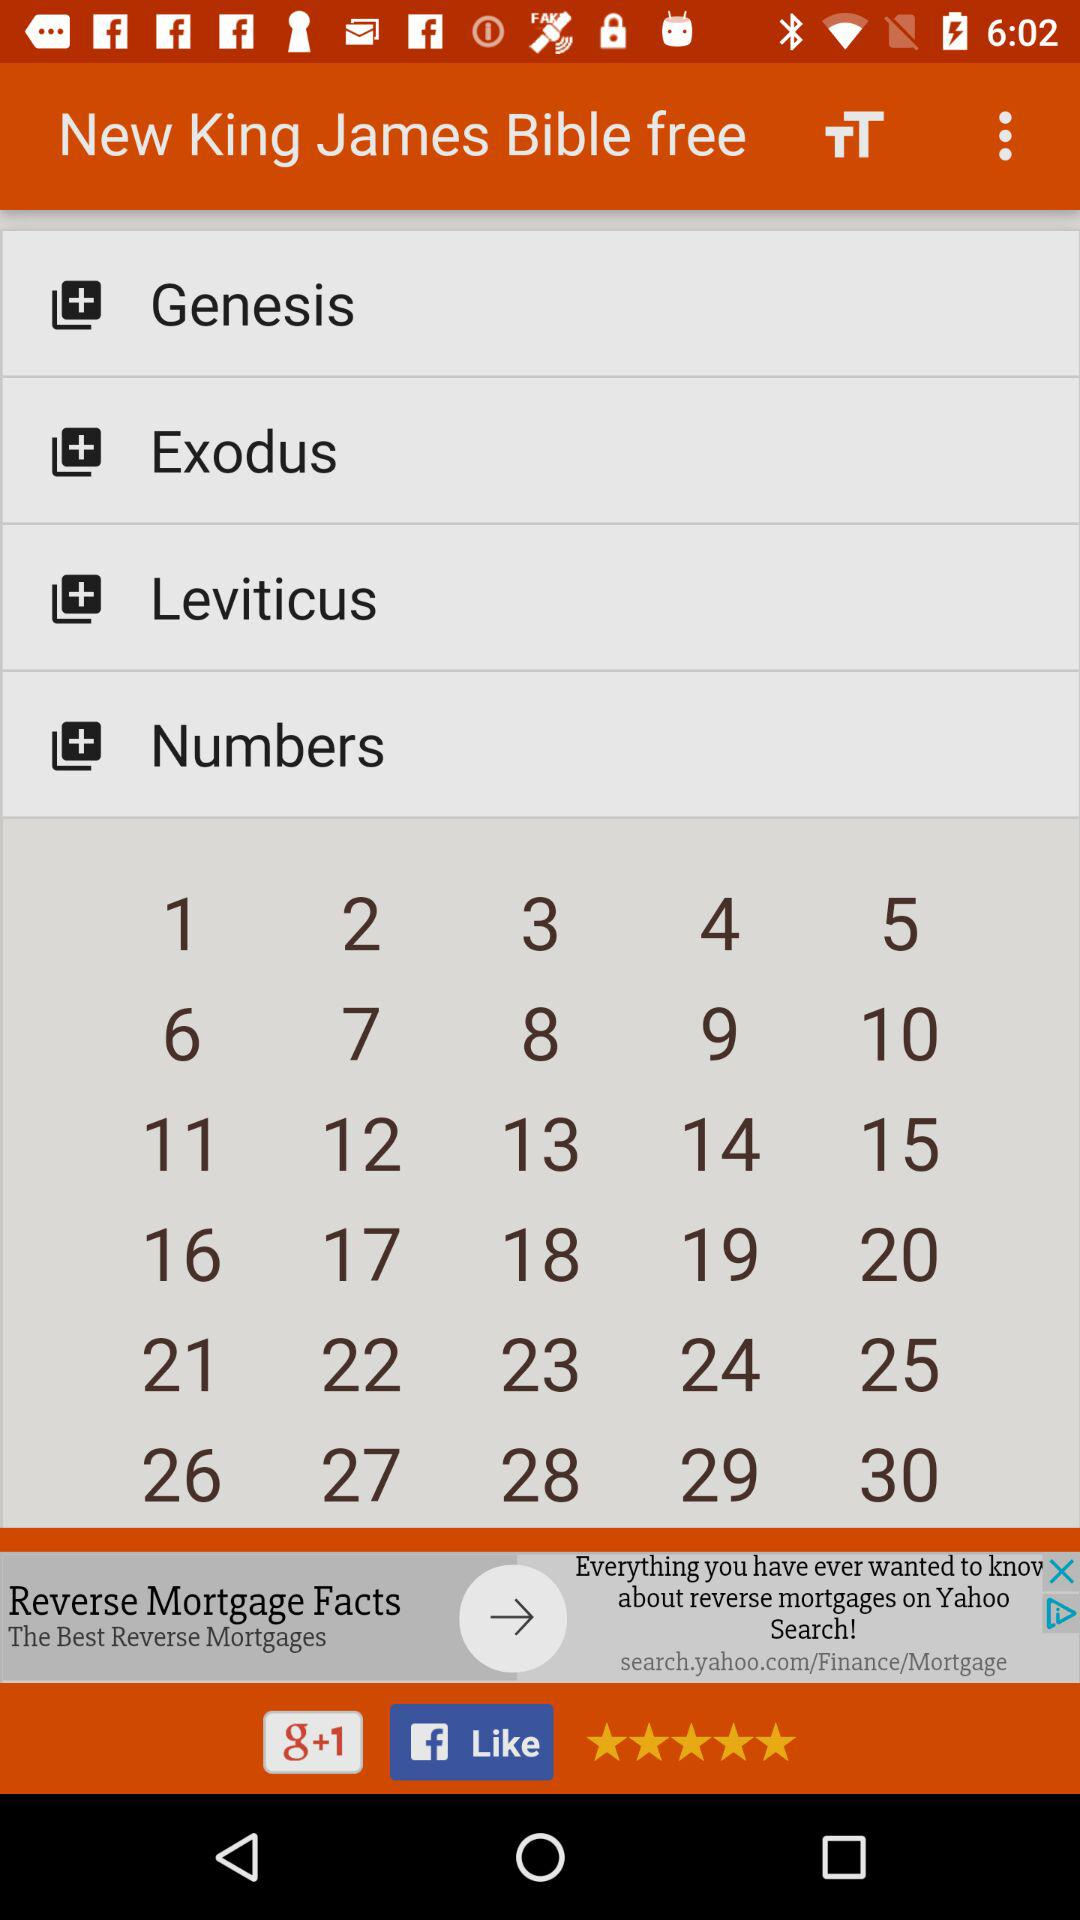How many ratings are there in this? The rating is 5 stars. 